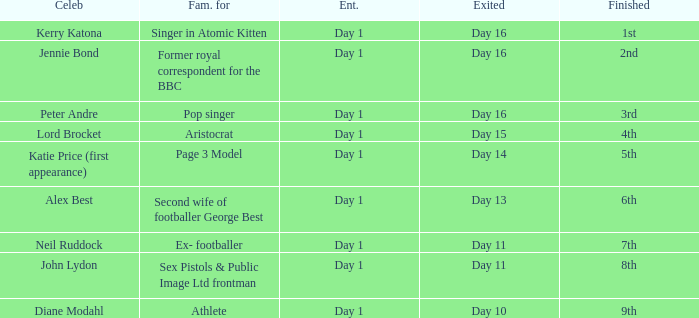Name the finished for exited day 13 6th. 